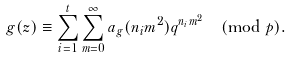Convert formula to latex. <formula><loc_0><loc_0><loc_500><loc_500>g ( z ) \equiv \sum _ { i = 1 } ^ { t } \sum _ { m = 0 } ^ { \infty } a _ { g } ( n _ { i } m ^ { 2 } ) q ^ { n _ { i } m ^ { 2 } } \pmod { p } .</formula> 